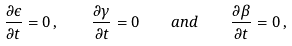<formula> <loc_0><loc_0><loc_500><loc_500>\frac { \partial \epsilon } { \partial t } = 0 \, , \quad \frac { \partial \gamma } { \partial t } = 0 \quad a n d \quad \frac { \partial \beta } { \partial t } = 0 \, ,</formula> 